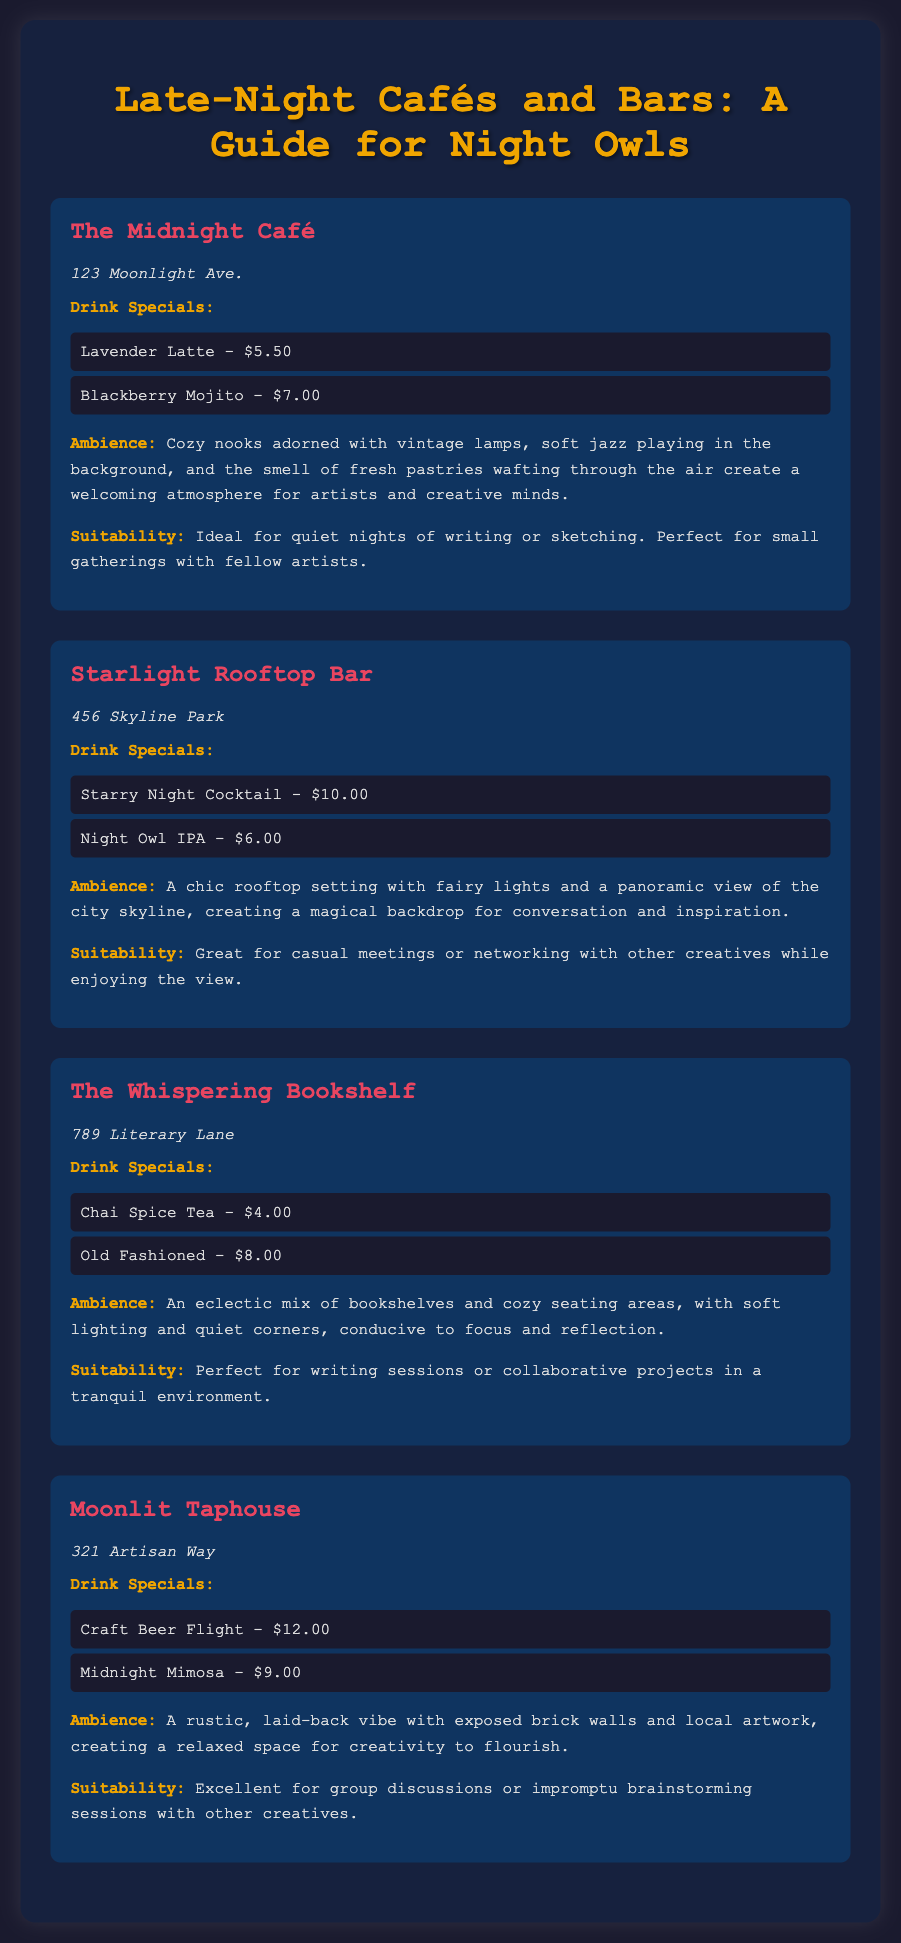What are the drink specials at The Midnight Café? The drink specials for The Midnight Café include Lavender Latte and Blackberry Mojito.
Answer: Lavender Latte, Blackberry Mojito What is the address of Starlight Rooftop Bar? The address is stated at the beginning of the venue description.
Answer: 456 Skyline Park What is the ambience of The Whispering Bookshelf? The ambience of The Whispering Bookshelf is described as an eclectic mix of bookshelves and cozy seating areas.
Answer: Eclectic mix of bookshelves and cozy seating areas Which venue is perfect for small gatherings with fellow artists? The suitability description for The Midnight Café indicates it's ideal for small gatherings.
Answer: The Midnight Café How much is the Craft Beer Flight at Moonlit Taphouse? The price of the Craft Beer Flight is directly mentioned in the drink specials list.
Answer: $12.00 What type of environment does Moonlit Taphouse provide? The document mentions the environment as rustic and laid-back with local artwork.
Answer: Rustic, laid-back Which drink special is priced at $9.00? The document lists the Midnight Mimosa priced at $9.00 under drink specials for Moonlit Taphouse.
Answer: Midnight Mimosa What is the label color for drink specials? The label color for drink specials is specified in the style of the document as a contrasting color.
Answer: #f0a500 What type of sessions is The Whispering Bookshelf suitable for? The suitability section indicates it is perfect for writing sessions or collaborative projects.
Answer: Writing sessions or collaborative projects 